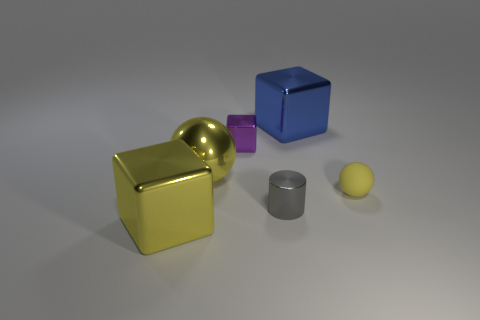Add 1 large cyan matte cubes. How many objects exist? 7 Subtract all spheres. How many objects are left? 4 Subtract 2 yellow balls. How many objects are left? 4 Subtract all small purple metallic blocks. Subtract all yellow rubber spheres. How many objects are left? 4 Add 4 purple metallic cubes. How many purple metallic cubes are left? 5 Add 3 large rubber things. How many large rubber things exist? 3 